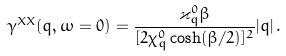Convert formula to latex. <formula><loc_0><loc_0><loc_500><loc_500>\gamma ^ { X X } ( q , \omega = 0 ) = \frac { \varkappa ^ { 0 } _ { q } \beta } { [ 2 \chi ^ { 0 } _ { q } \cosh ( \beta / 2 ) ] ^ { 2 } } | q | \, .</formula> 